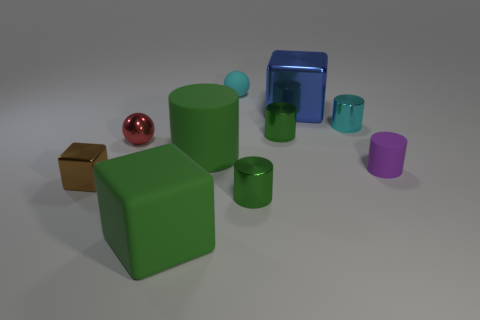Subtract all rubber blocks. How many blocks are left? 2 Subtract 0 red cylinders. How many objects are left? 10 Subtract all blocks. How many objects are left? 7 Subtract 2 cylinders. How many cylinders are left? 3 Subtract all gray balls. Subtract all green cylinders. How many balls are left? 2 Subtract all yellow spheres. How many brown cylinders are left? 0 Subtract all large gray cylinders. Subtract all tiny red shiny objects. How many objects are left? 9 Add 7 green cubes. How many green cubes are left? 8 Add 2 small green cylinders. How many small green cylinders exist? 4 Subtract all purple cylinders. How many cylinders are left? 4 